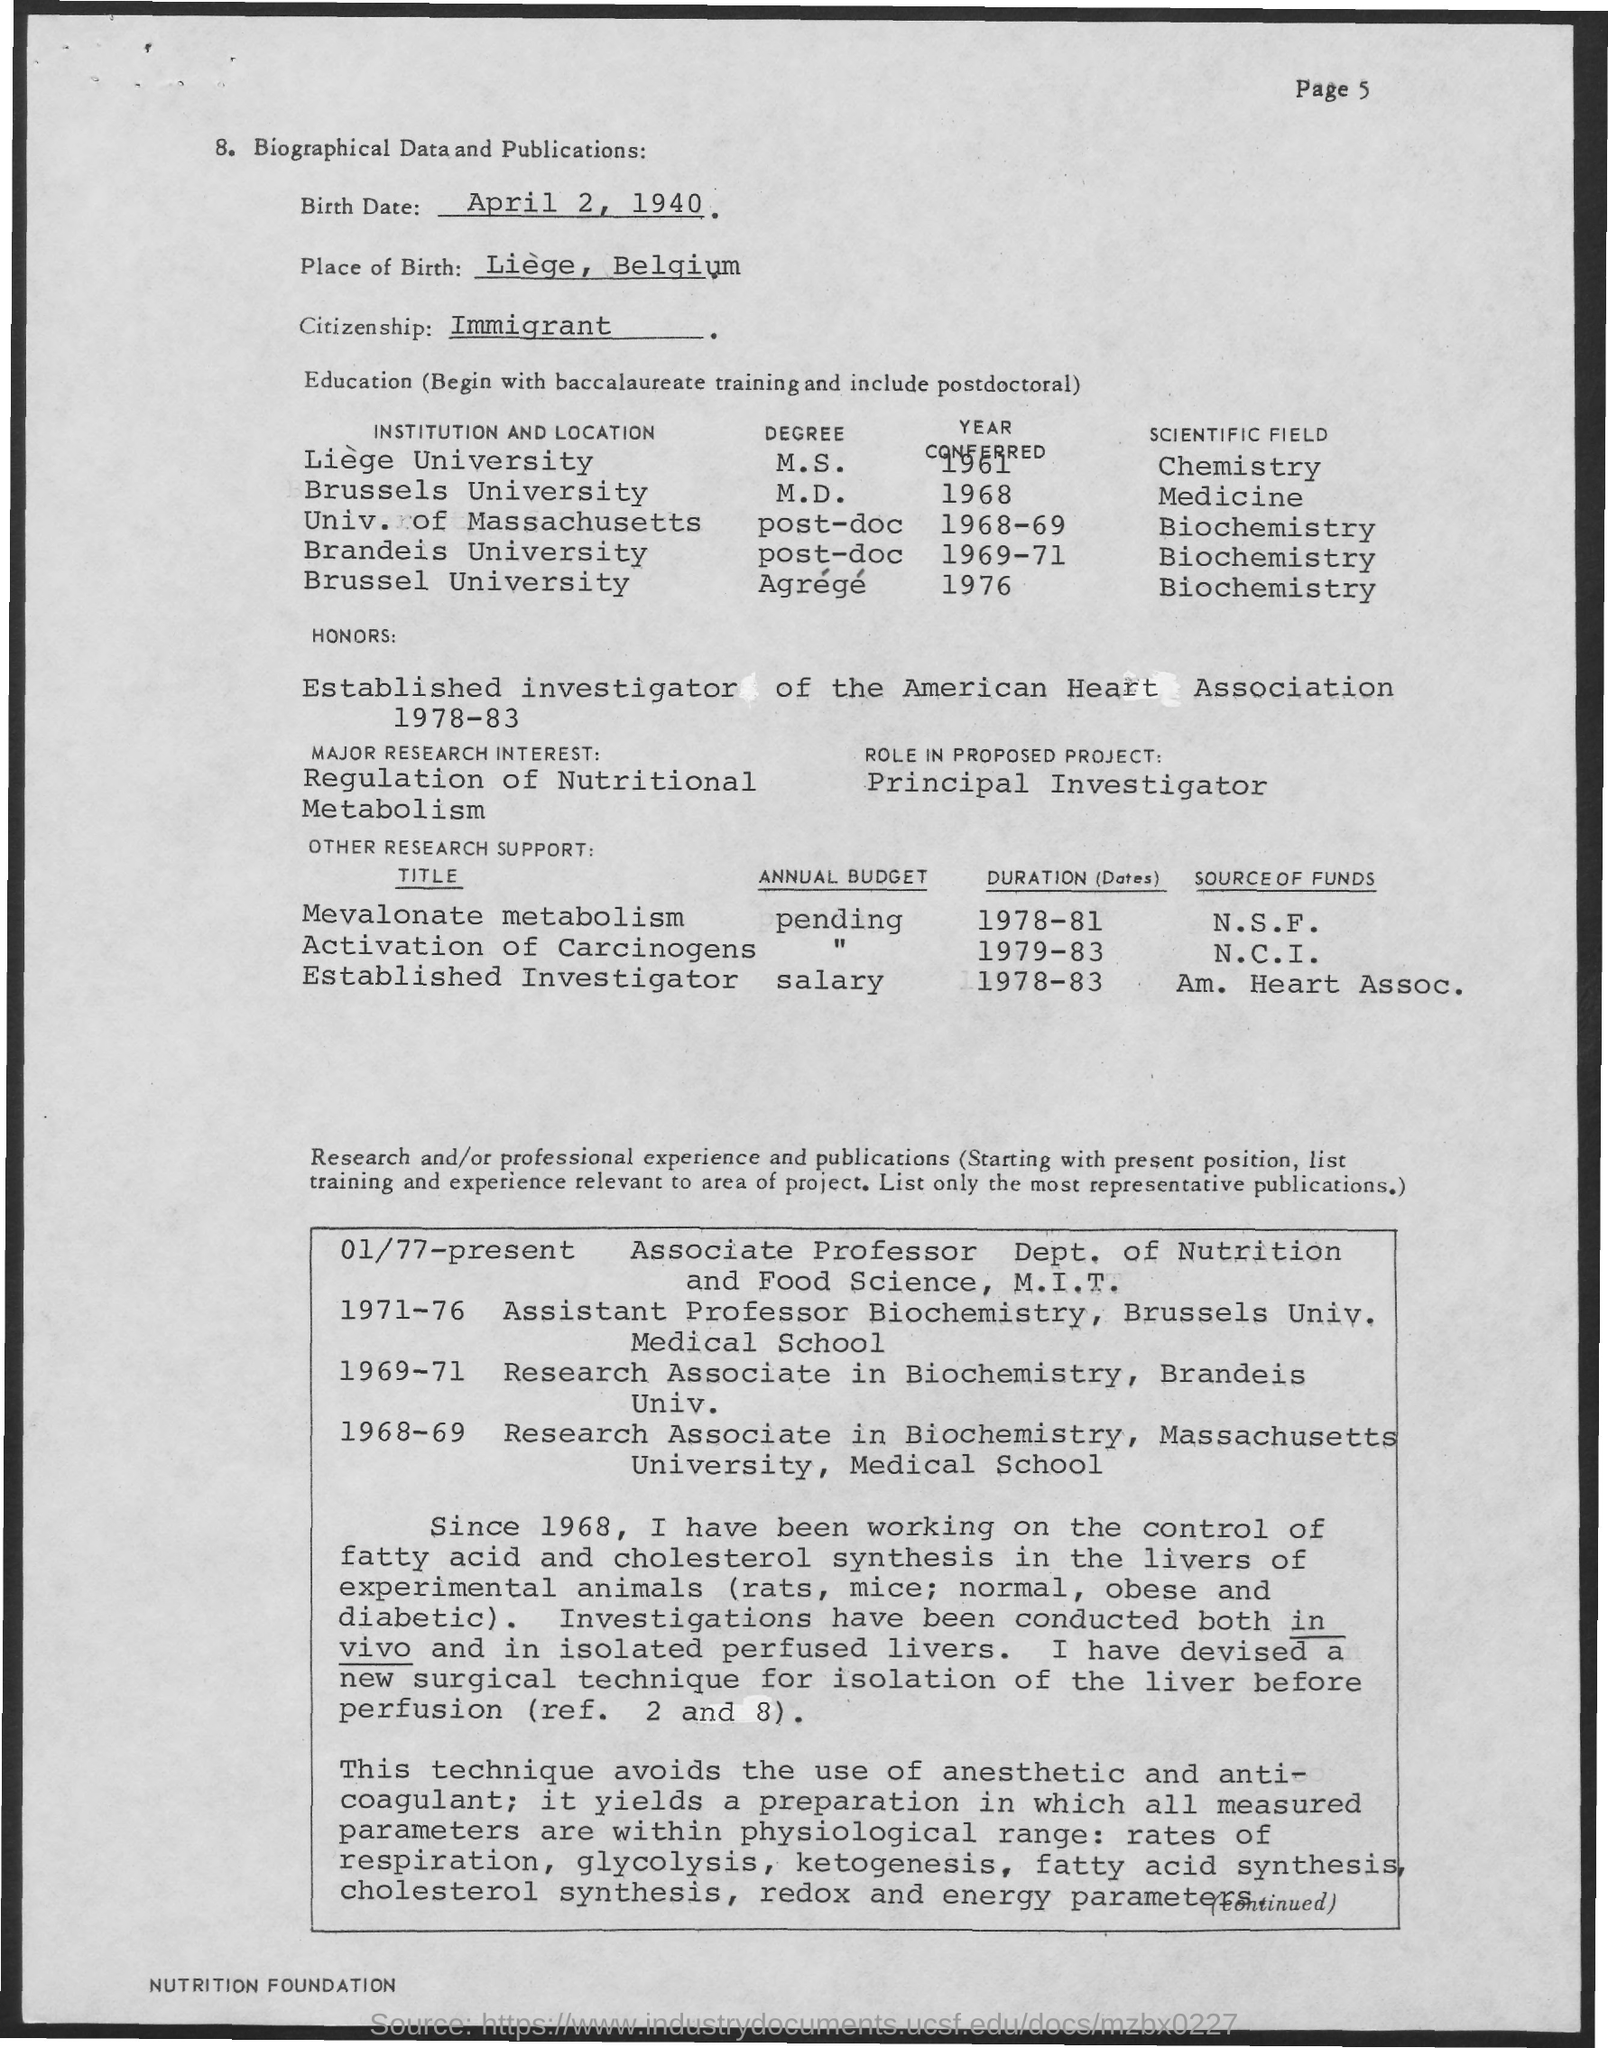Point out several critical features in this image. This document belongs to an immigrant person. The place of birth of the person to whom this document belongs is Liege, Belgium. The date of birth mentioned in the document is April 2, 1940. 